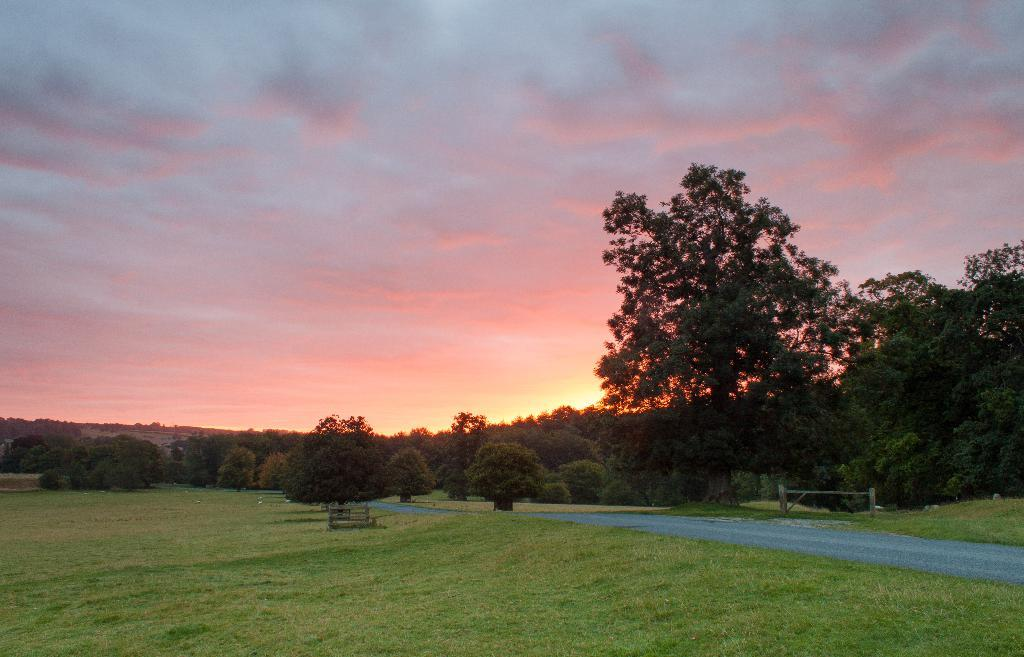What is located in the center of the image? There are trees in the center of the image. What type of vegetation can be seen at the bottom of the image? There is grass at the bottom of the image. What can be seen towards the right side of the image? There is a road towards the right of the image. What is visible at the top of the image? The sky is visible at the top of the image. What can be observed in the sky? Clouds are present in the sky. Can you tell me how many rabbits are sitting on the tray in the image? There is no tray or rabbits present in the image. What type of nail is being used to hang the clouds in the image? There are no nails or clouds being hung in the image; the clouds are naturally present in the sky. 